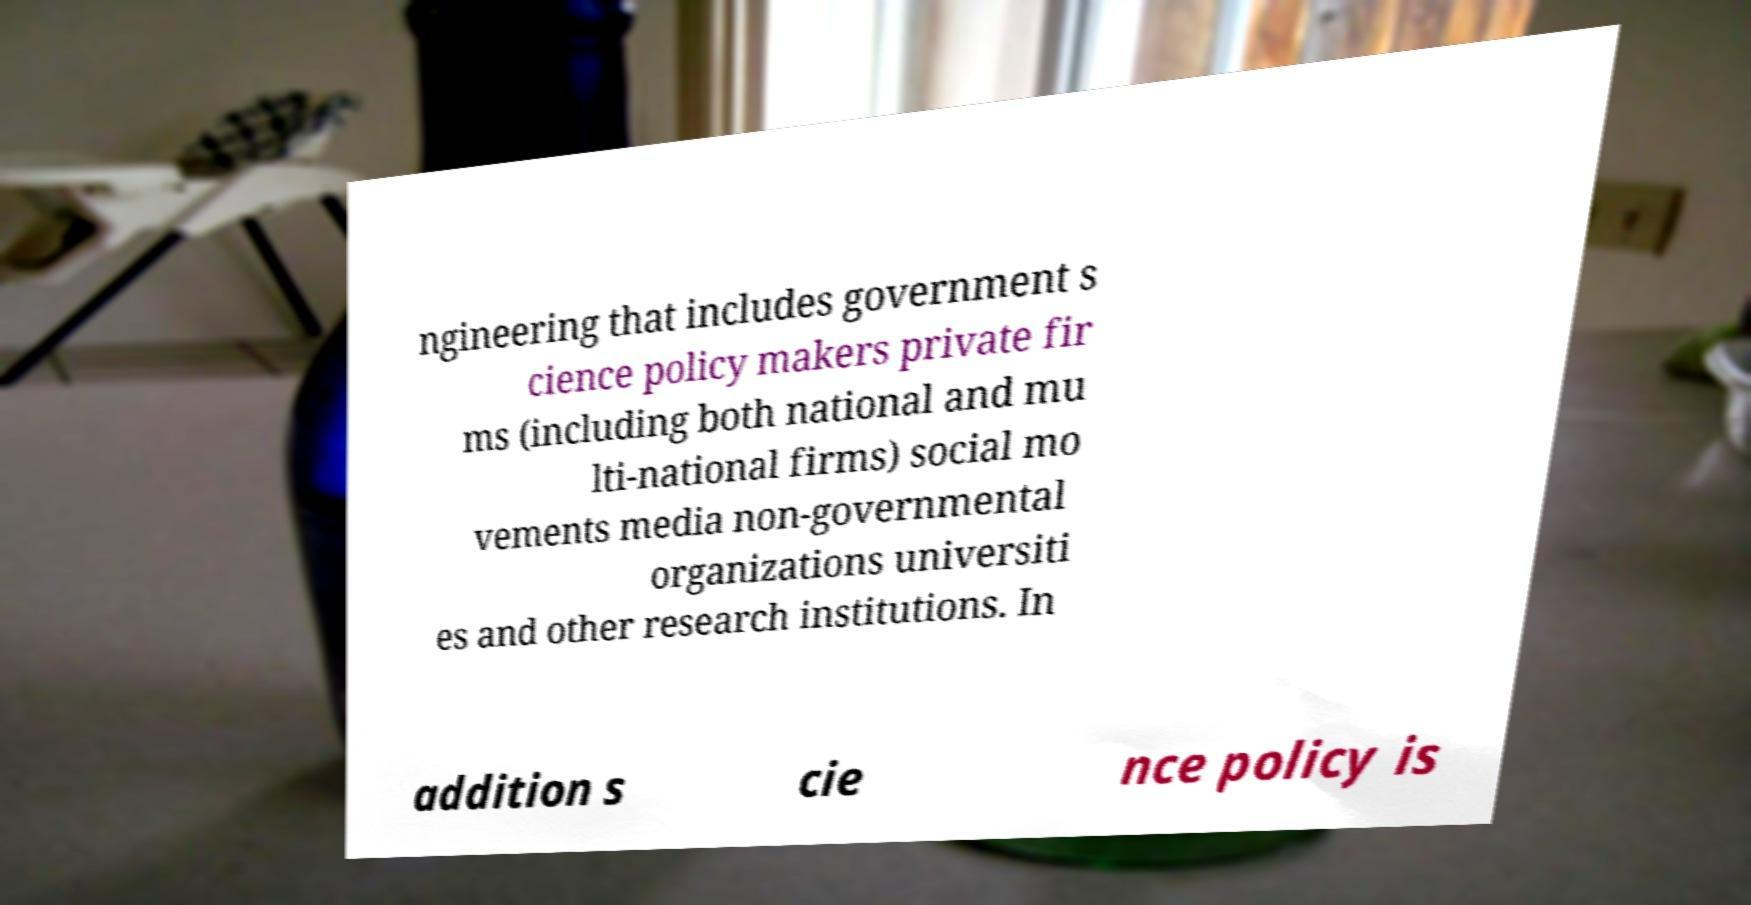Can you read and provide the text displayed in the image?This photo seems to have some interesting text. Can you extract and type it out for me? ngineering that includes government s cience policy makers private fir ms (including both national and mu lti-national firms) social mo vements media non-governmental organizations universiti es and other research institutions. In addition s cie nce policy is 